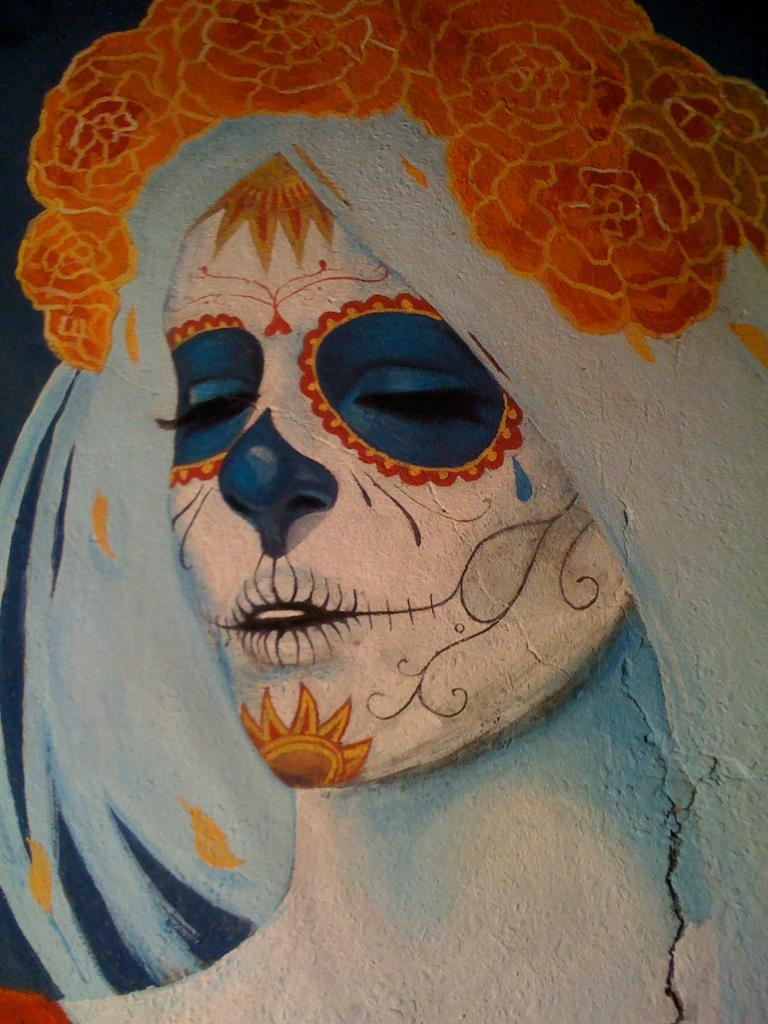What is the main subject of the image? The main subject of the image is a painting. What does the painting depict? The painting depicts a person. What type of hat is the person in the painting wearing? There is no hat visible on the person in the painting. What news event is the person in the painting reporting on? The image does not depict a news event or a person reporting on one. 